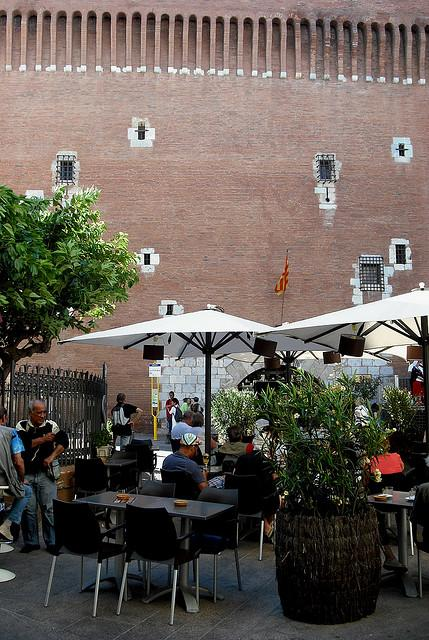Umbrellas provide what here? Please explain your reasoning. shade. It is a sunny day with no rain 